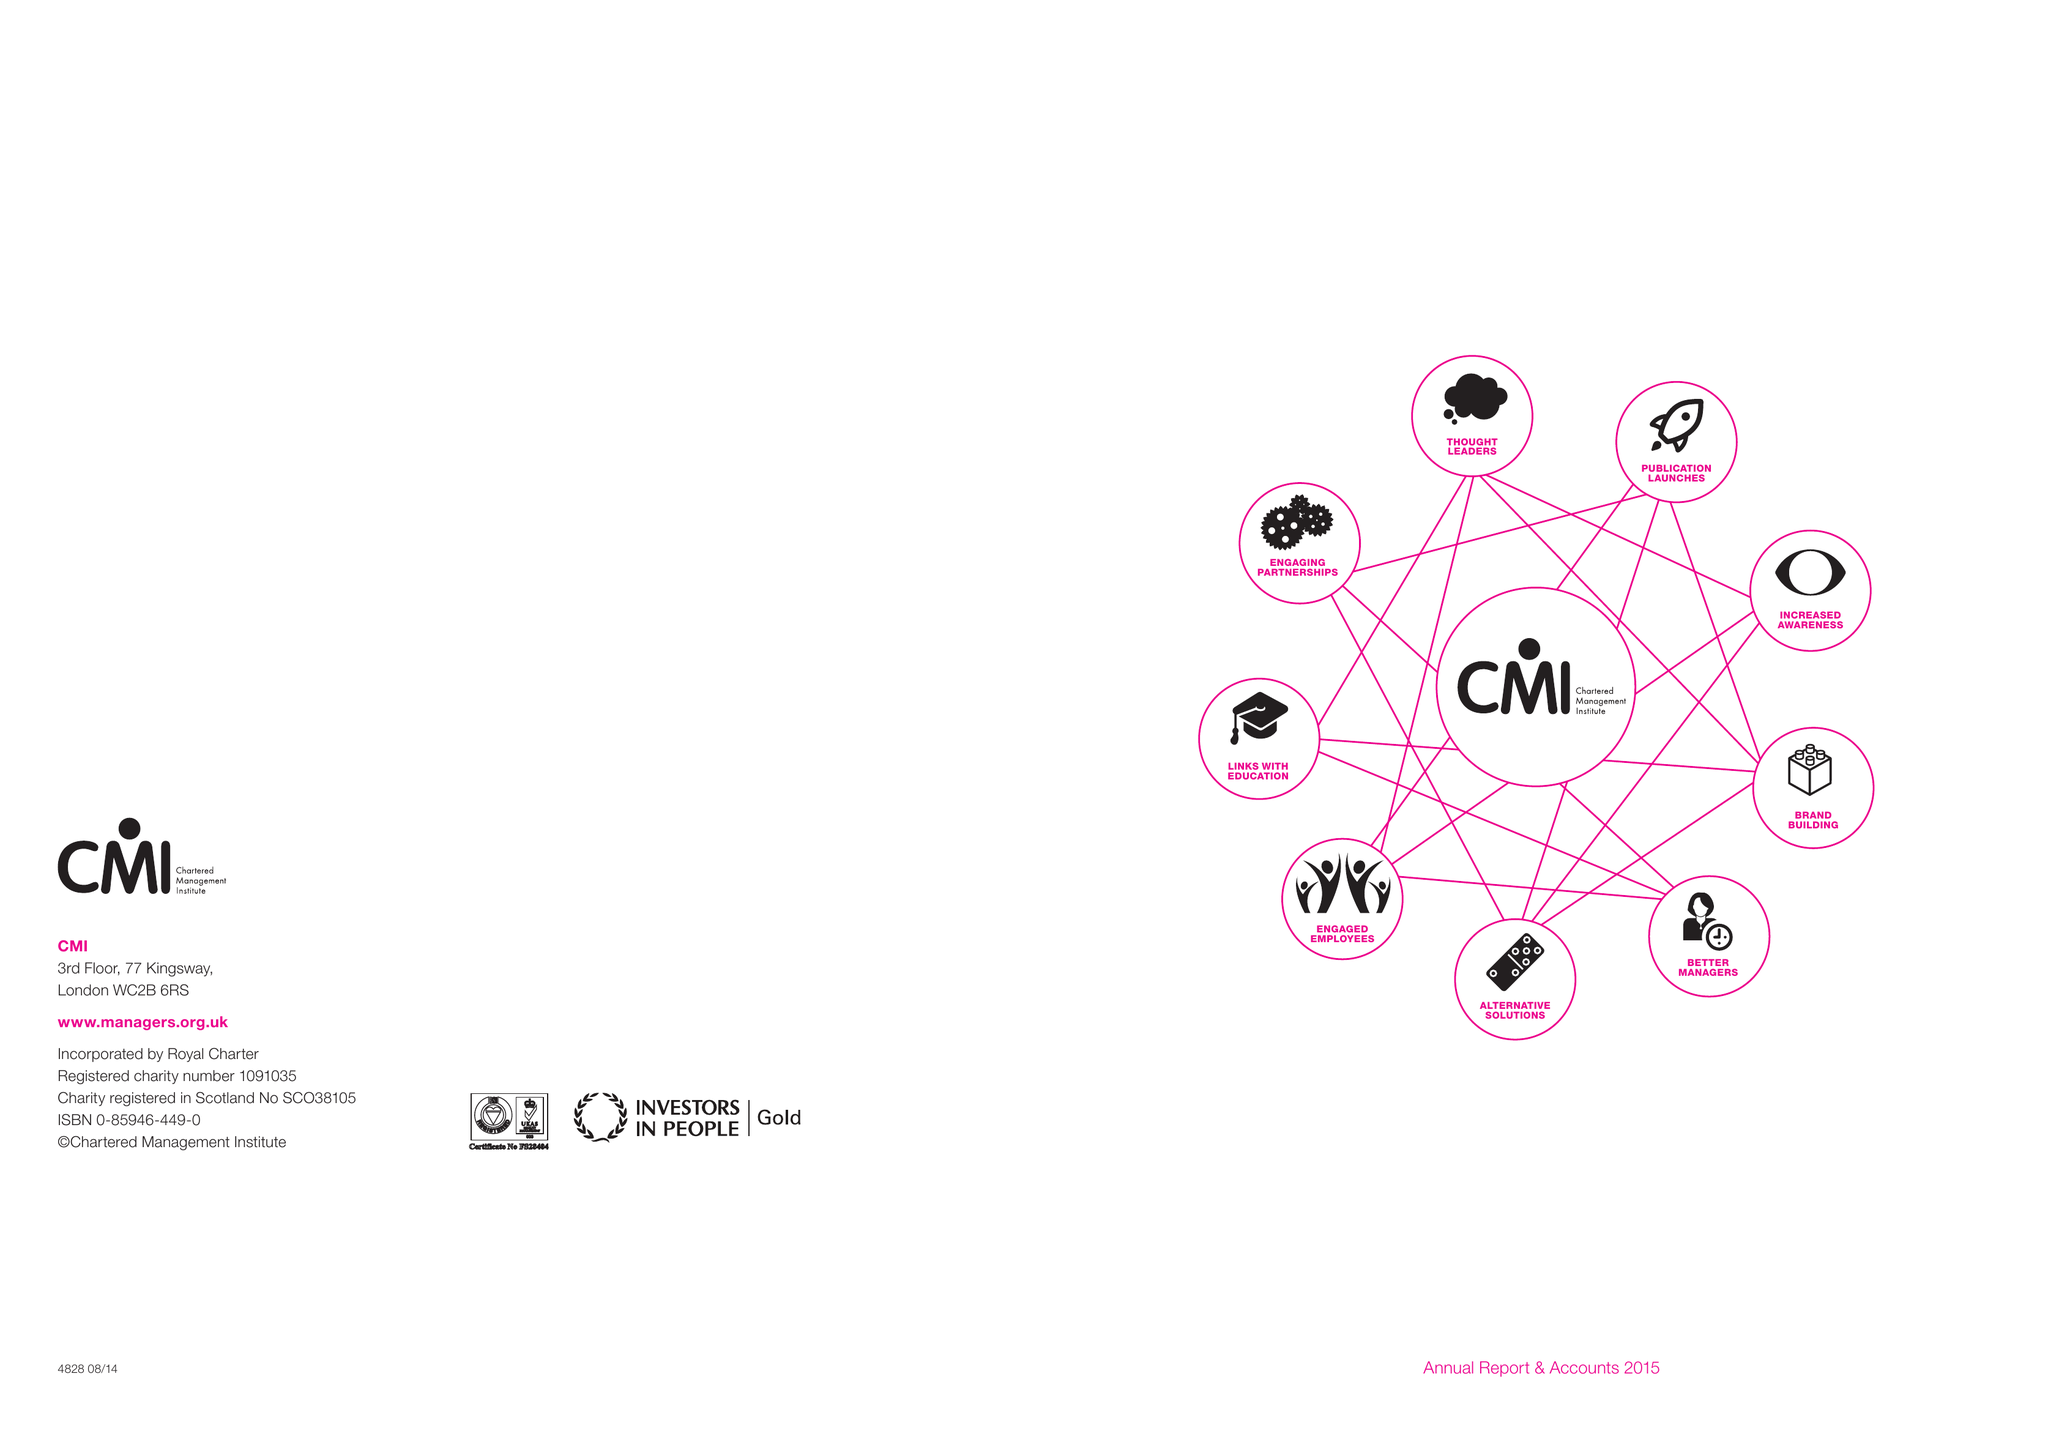What is the value for the spending_annually_in_british_pounds?
Answer the question using a single word or phrase. 10212000.00 